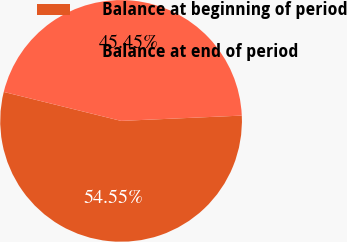<chart> <loc_0><loc_0><loc_500><loc_500><pie_chart><fcel>Balance at beginning of period<fcel>Balance at end of period<nl><fcel>54.55%<fcel>45.45%<nl></chart> 